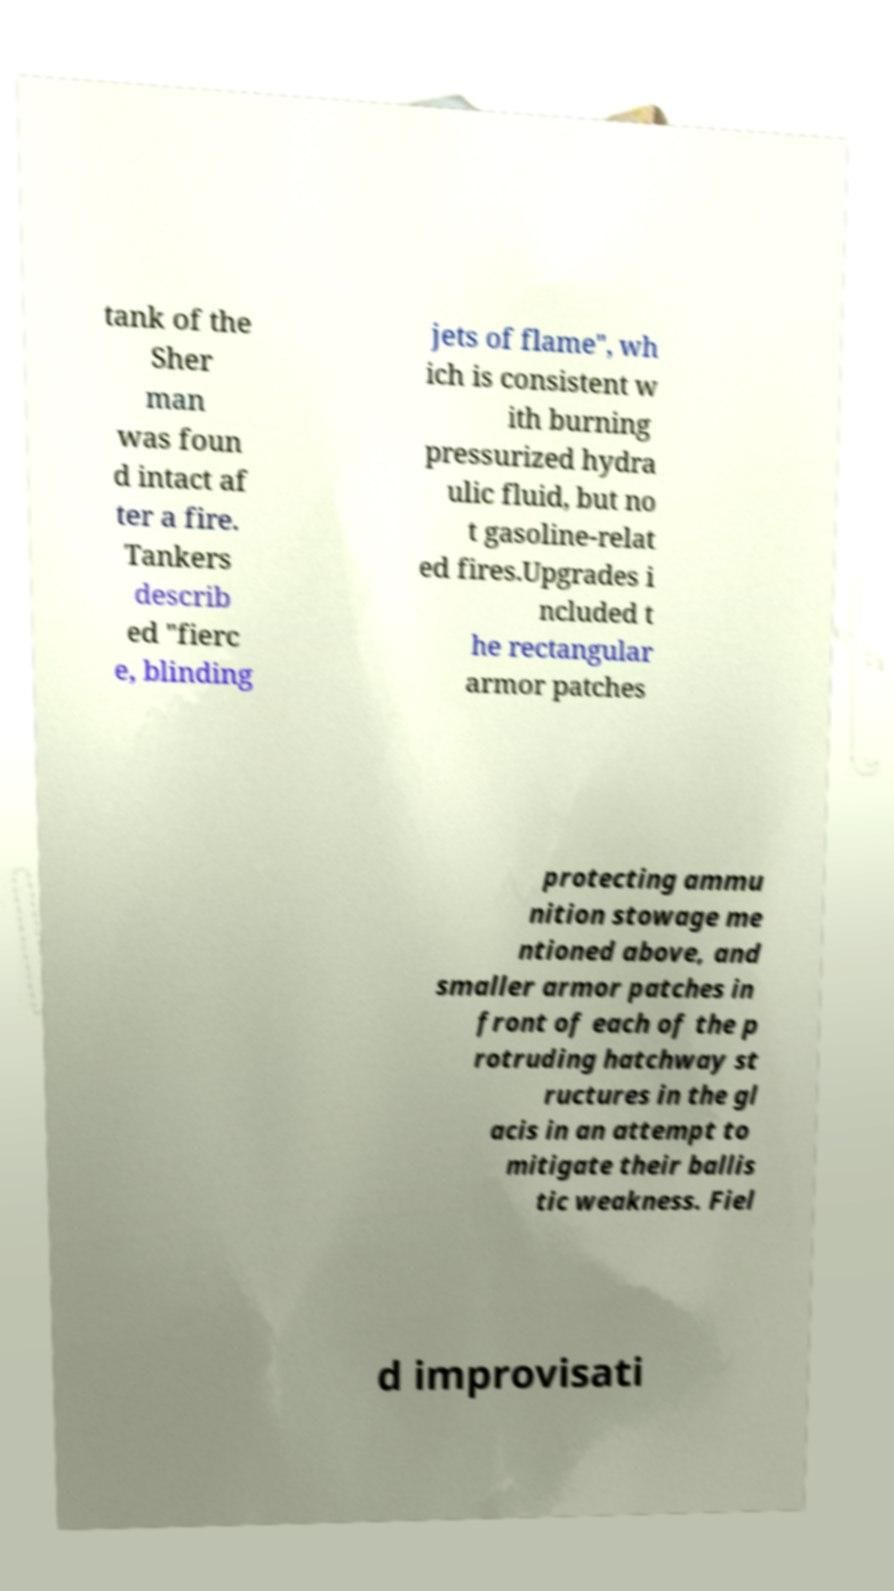Could you assist in decoding the text presented in this image and type it out clearly? tank of the Sher man was foun d intact af ter a fire. Tankers describ ed "fierc e, blinding jets of flame", wh ich is consistent w ith burning pressurized hydra ulic fluid, but no t gasoline-relat ed fires.Upgrades i ncluded t he rectangular armor patches protecting ammu nition stowage me ntioned above, and smaller armor patches in front of each of the p rotruding hatchway st ructures in the gl acis in an attempt to mitigate their ballis tic weakness. Fiel d improvisati 